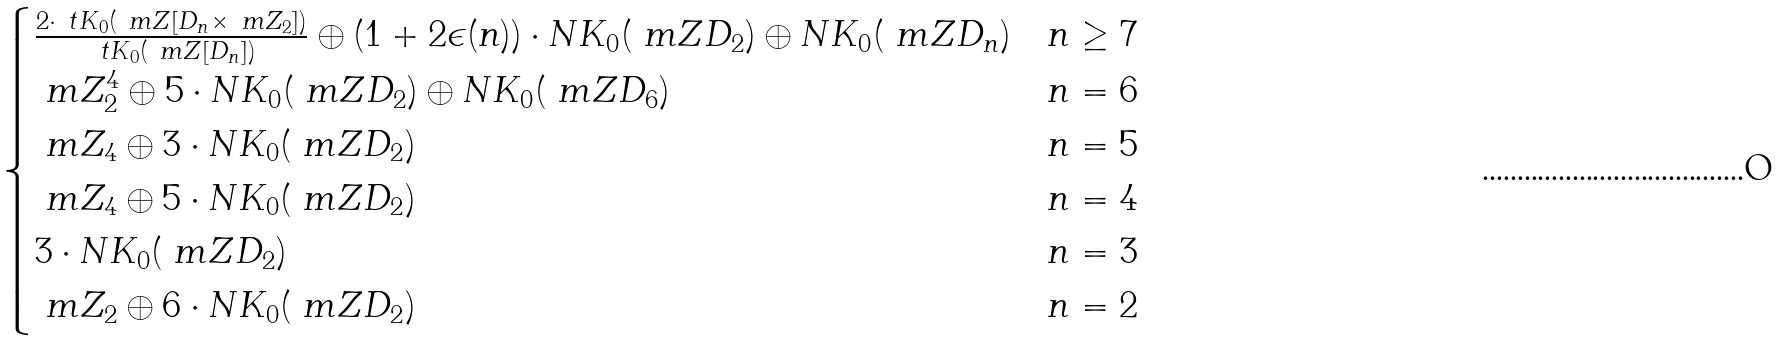Convert formula to latex. <formula><loc_0><loc_0><loc_500><loc_500>\begin{cases} \frac { 2 \cdot \ t K _ { 0 } ( \ m Z [ D _ { n } \times \ m Z _ { 2 } ] ) } { \ t K _ { 0 } ( \ m Z [ D _ { n } ] ) } \oplus ( 1 + 2 \epsilon ( n ) ) \cdot N K _ { 0 } ( \ m Z D _ { 2 } ) \oplus N K _ { 0 } ( \ m Z D _ { n } ) & n \geq 7 \\ \ m Z _ { 2 } ^ { 4 } \oplus 5 \cdot N K _ { 0 } ( \ m Z D _ { 2 } ) \oplus N K _ { 0 } ( \ m Z D _ { 6 } ) & n = 6 \\ \ m Z _ { 4 } \oplus 3 \cdot N K _ { 0 } ( \ m Z D _ { 2 } ) & n = 5 \\ \ m Z _ { 4 } \oplus 5 \cdot N K _ { 0 } ( \ m Z D _ { 2 } ) & n = 4 \\ 3 \cdot N K _ { 0 } ( \ m Z D _ { 2 } ) & n = 3 \\ \ m Z _ { 2 } \oplus 6 \cdot N K _ { 0 } ( \ m Z D _ { 2 } ) & n = 2 \end{cases}</formula> 